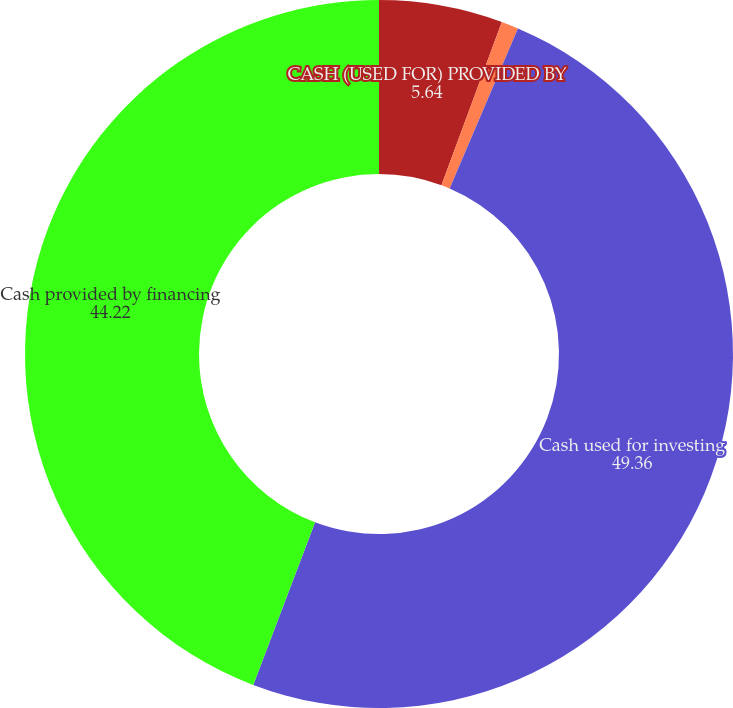<chart> <loc_0><loc_0><loc_500><loc_500><pie_chart><fcel>CASH (USED FOR) PROVIDED BY<fcel>Deposits investments and other<fcel>Cash used for investing<fcel>Cash provided by financing<nl><fcel>5.64%<fcel>0.78%<fcel>49.36%<fcel>44.22%<nl></chart> 